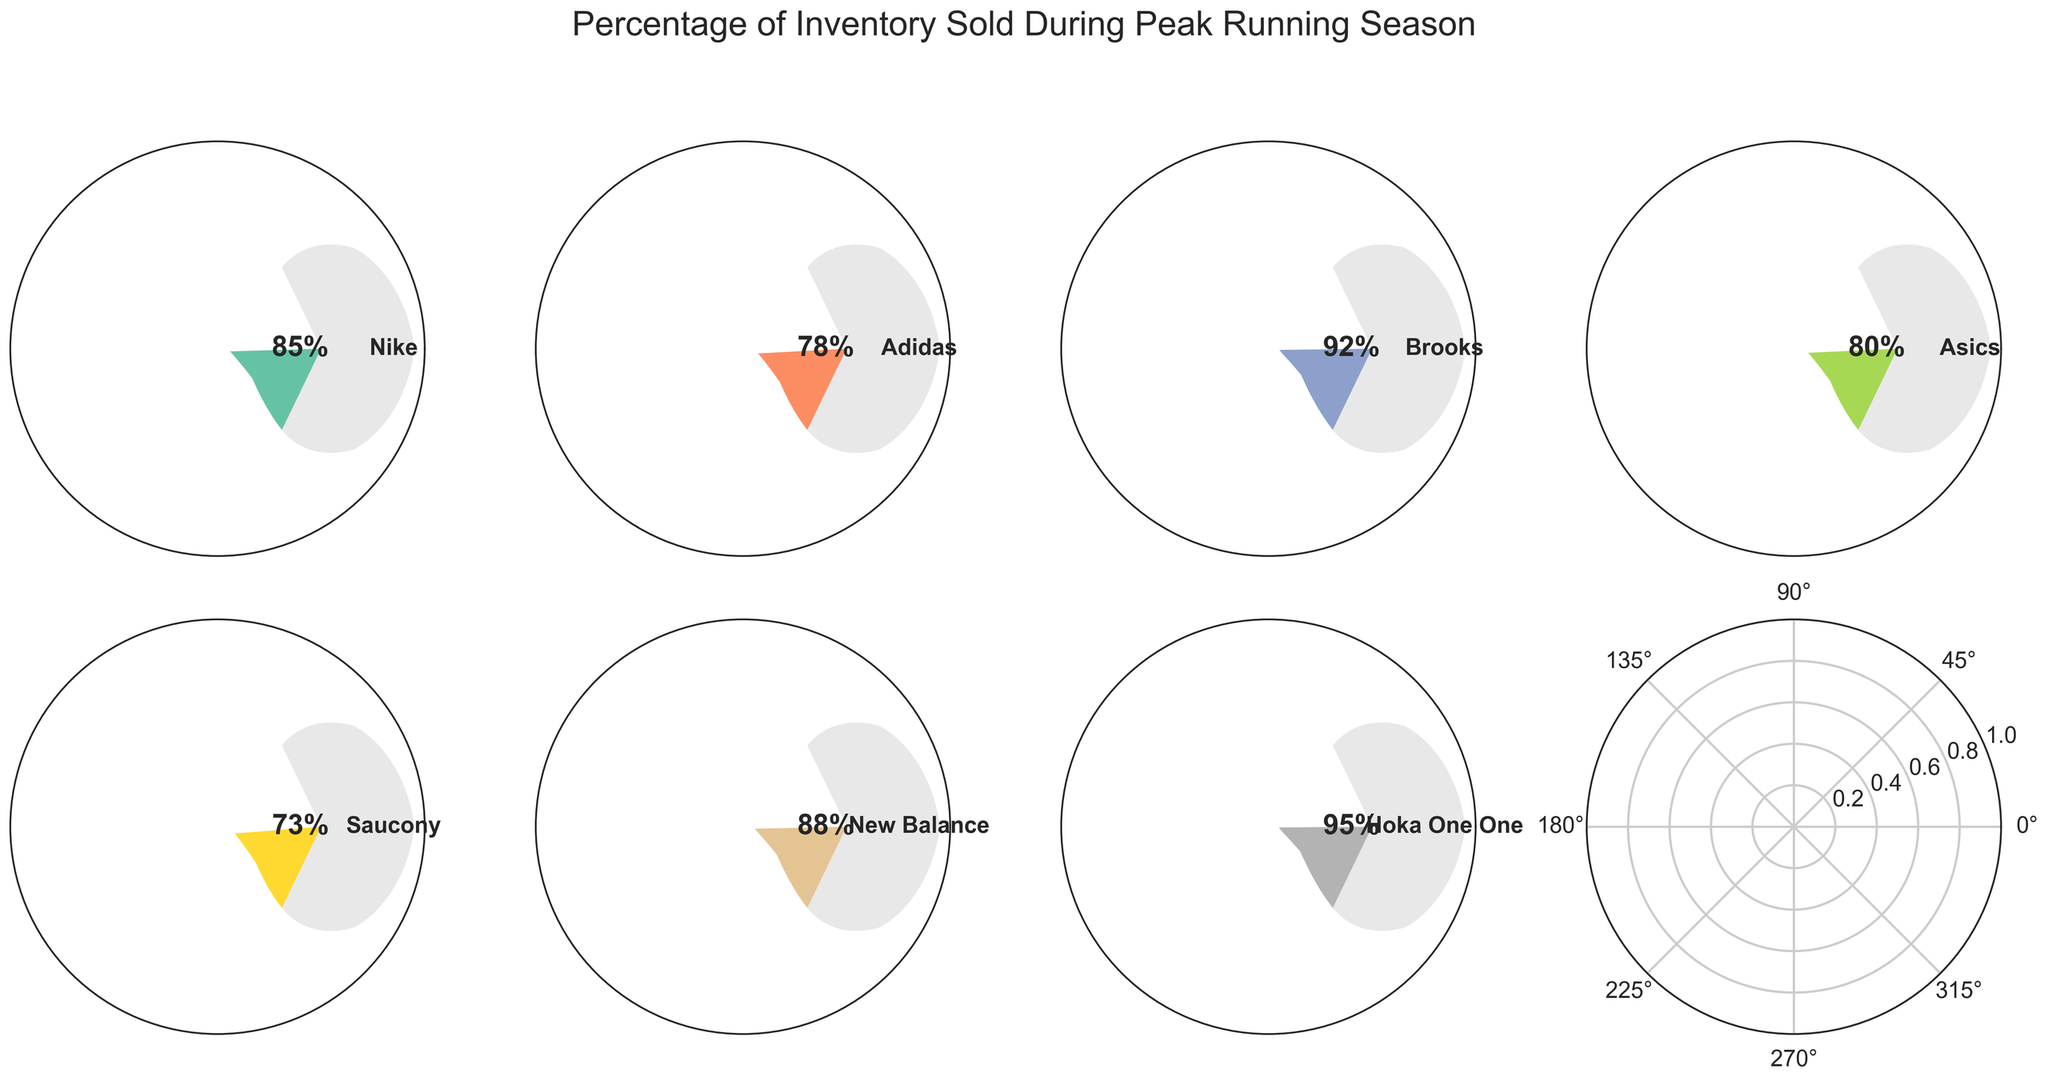What is the title of the figure? The title of the figure is located at the top, above all the gauge charts.
Answer: Percentage of Inventory Sold During Peak Running Season Which brand has the highest percentage of inventory sold? By looking at the gauge charts, identify the brand with the highest percentage shown. Hoka One One has the highest percentage.
Answer: Hoka One One Which brand has the lowest percentage of inventory sold? By looking at the gauge charts, identify the brand with the lowest percentage shown. Saucony has the lowest percentage.
Answer: Saucony Which two brands sold more than 90% of their inventory? By examining each gauge chart, identify the brands with percentages greater than 90%. Both Hoka One One and Brooks exceed this percentage.
Answer: Hoka One One, Brooks How many brands sold less than 80% of their inventory? Count the number of gauge charts that display percentages below 80%. Only Saucony has a percentage below 80%.
Answer: One What is the average percentage of inventory sold across all brands? Sum the percentages of all brands and divide by the number of brands: (85 + 78 + 92 + 80 + 73 + 88 + 95) / 7 = 591/7.
Answer: 84.43% Which brand has a percentage difference of 10% or less compared to Nike? Calculate the absolute difference between Nike's percentage (85%) and other brands'. Identify the brands where the difference is 10% or less (Adidas 78%, Asics 80%, New Balance 88%).
Answer: Adidas, Asics, New Balance How does the sales performance of Adidas compare to Asics? Compare the percentages directly from the gauge charts. Adidas sold 78%, and Asics sold 80%.
Answer: Asics sold more What color is used for the Hoka One One gauge chart? Each gauge chart is colored differently. Identify the color associated with Hoka One One. Hoka One One is represented by the last gauge chart color from the color map Set2.
Answer: The color specific to Hoka One One as per the color map Which brands sold between 70% and 80% of their inventory? Check each gauge chart and identify the brands with percentages between 70% and 80%. Adidas, Asics, and Saucony fall within this range.
Answer: Adidas, Asics, Saucony 